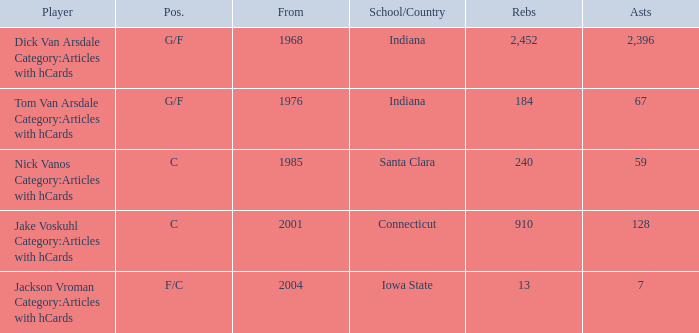What is the mean number of rebounds for players with over 67 assists since 1976? None. 